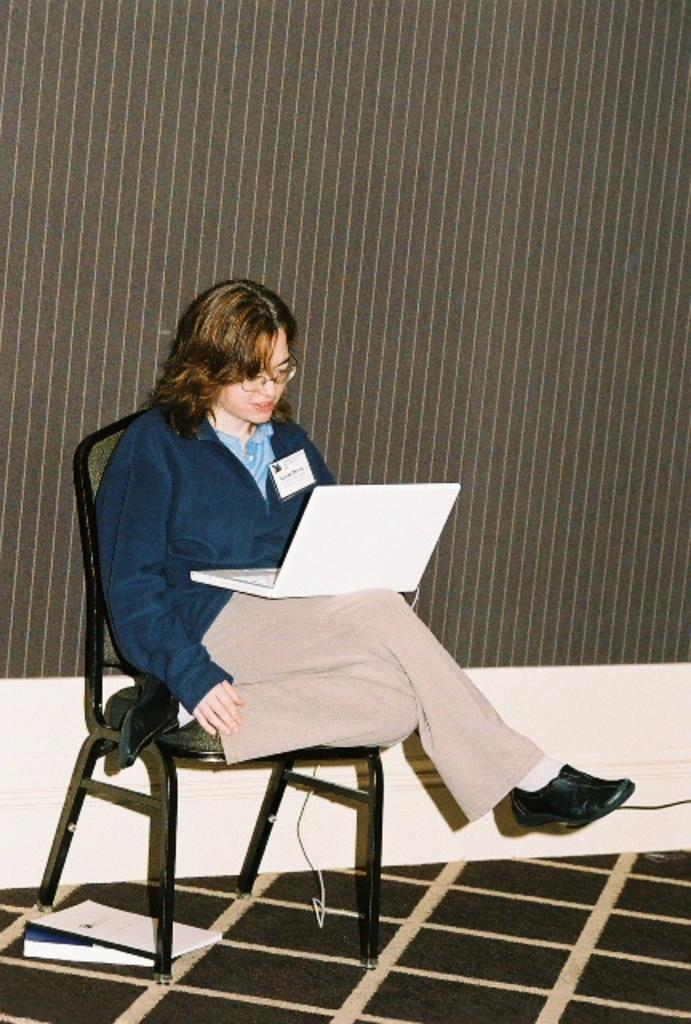Who is the main subject in the image? There is a woman in the image. What is the woman doing in the image? The woman is sitting on a chair. What object is the woman holding in the image? The woman is holding a laptop. What type of distribution system is being used by the woman in the image? There is no distribution system mentioned or visible in the image; the woman is simply sitting on a chair and holding a laptop. 